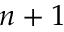<formula> <loc_0><loc_0><loc_500><loc_500>n + 1</formula> 